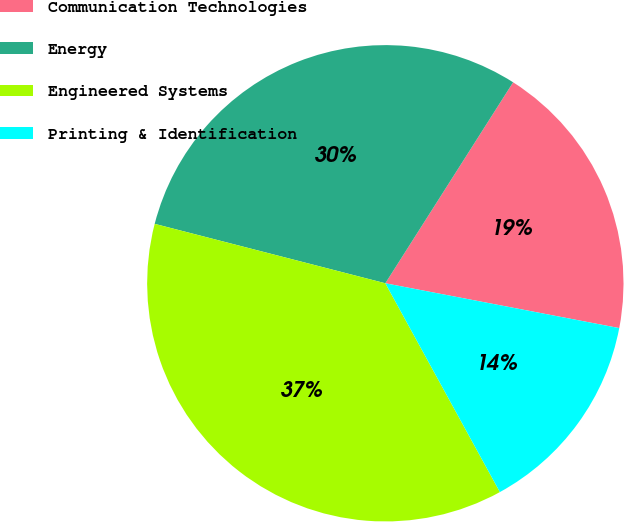Convert chart. <chart><loc_0><loc_0><loc_500><loc_500><pie_chart><fcel>Communication Technologies<fcel>Energy<fcel>Engineered Systems<fcel>Printing & Identification<nl><fcel>19.0%<fcel>30.0%<fcel>37.0%<fcel>14.0%<nl></chart> 